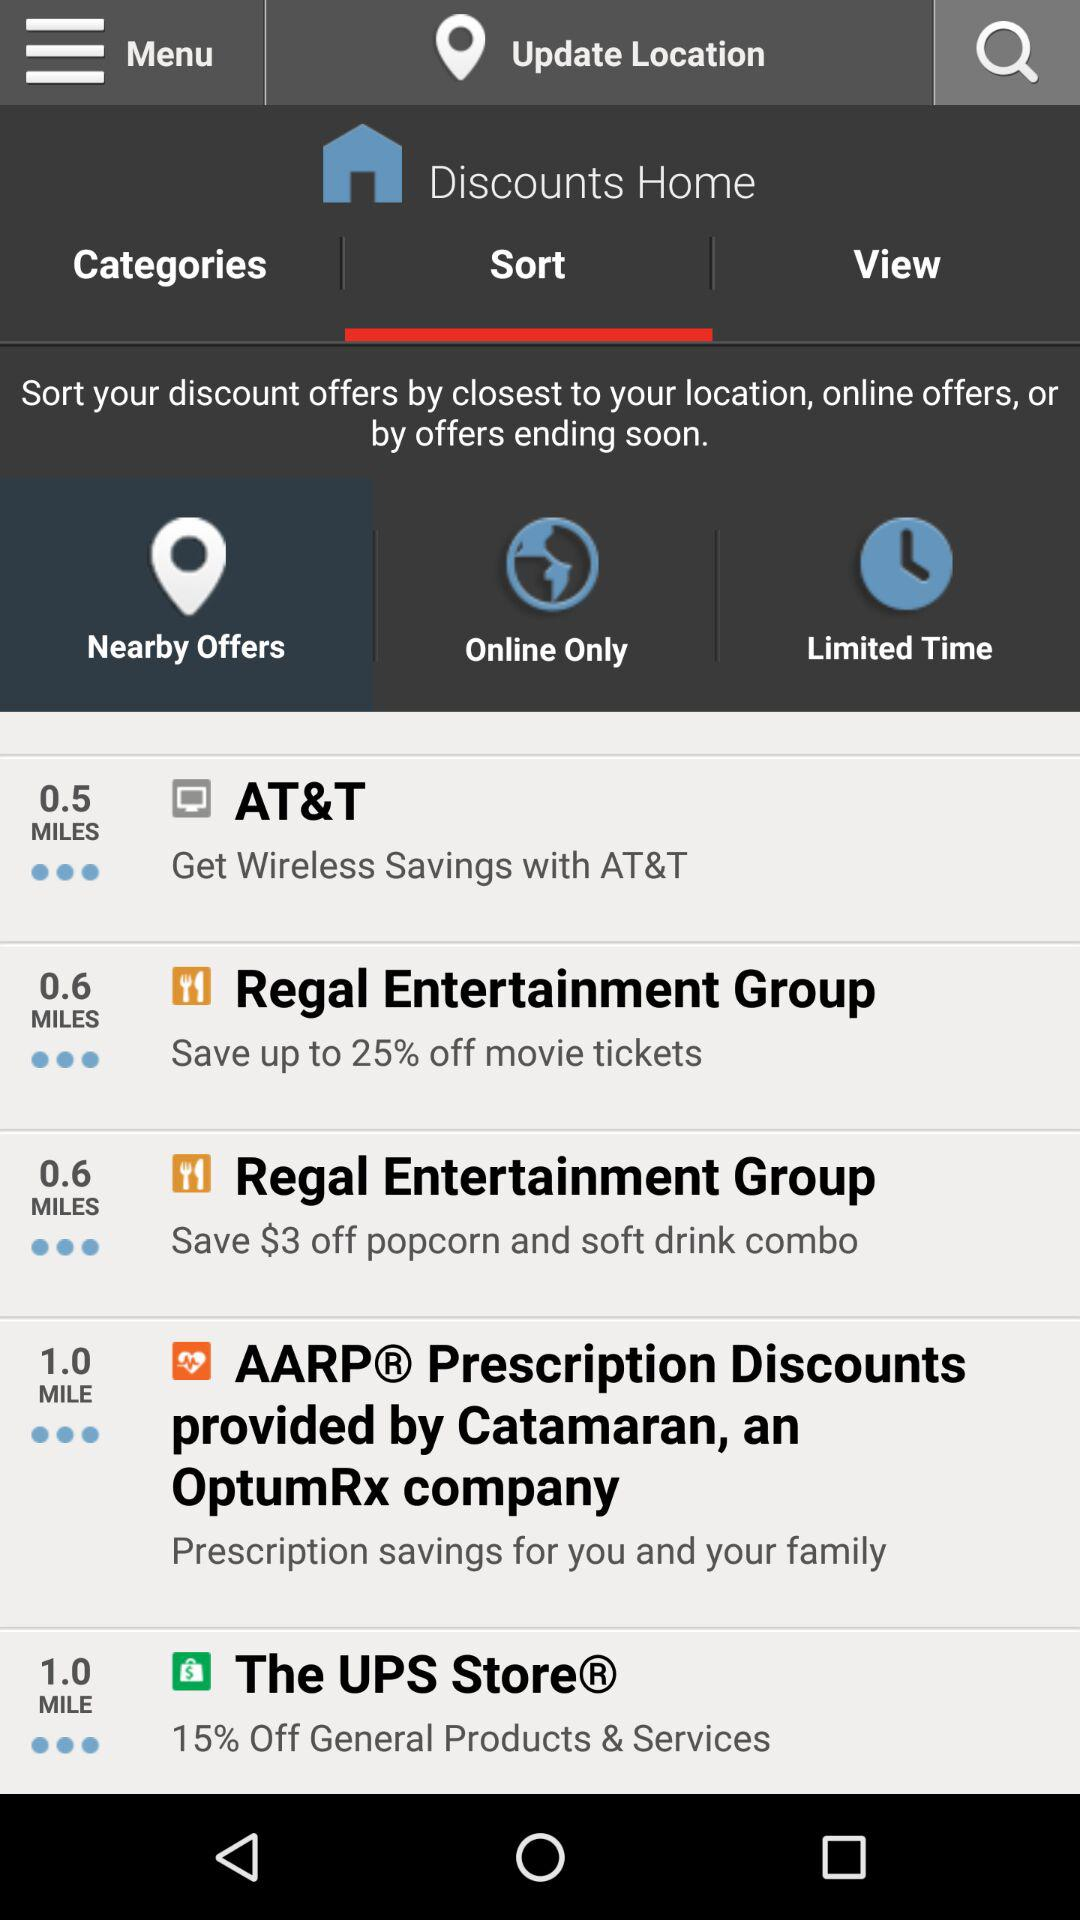How many miles away is the closest offer?
Answer the question using a single word or phrase. 0.5 miles 